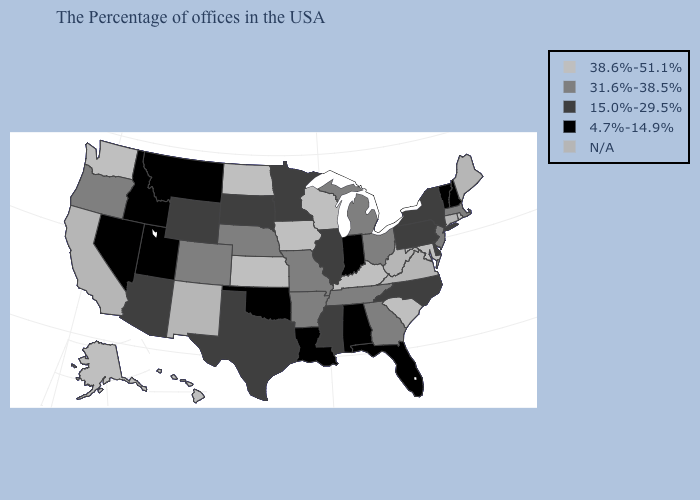Which states hav the highest value in the MidWest?
Write a very short answer. Wisconsin, Iowa, Kansas, North Dakota. What is the highest value in the USA?
Give a very brief answer. 38.6%-51.1%. What is the highest value in states that border Oklahoma?
Be succinct. 38.6%-51.1%. How many symbols are there in the legend?
Keep it brief. 5. What is the lowest value in the USA?
Short answer required. 4.7%-14.9%. Which states have the lowest value in the Northeast?
Keep it brief. New Hampshire, Vermont. What is the highest value in states that border Idaho?
Short answer required. 38.6%-51.1%. What is the highest value in the MidWest ?
Answer briefly. 38.6%-51.1%. Name the states that have a value in the range 31.6%-38.5%?
Give a very brief answer. Massachusetts, New Jersey, Ohio, Georgia, Michigan, Tennessee, Missouri, Arkansas, Nebraska, Colorado, Oregon. Does South Dakota have the lowest value in the USA?
Short answer required. No. How many symbols are there in the legend?
Quick response, please. 5. What is the value of North Carolina?
Concise answer only. 15.0%-29.5%. What is the value of Maryland?
Give a very brief answer. 38.6%-51.1%. What is the highest value in states that border Maine?
Keep it brief. 4.7%-14.9%. 